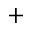<formula> <loc_0><loc_0><loc_500><loc_500>+</formula> 